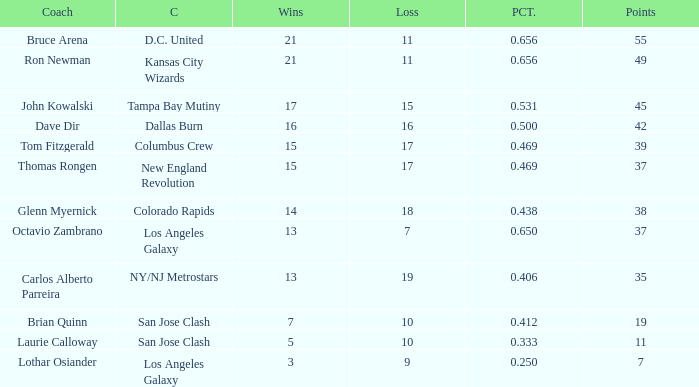What is the highest percent of Bruce Arena when he loses more than 11 games? None. 